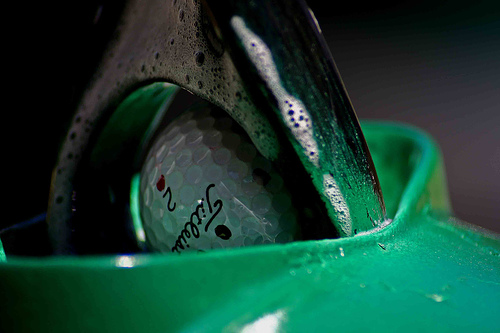<image>
Can you confirm if the ball is in the washer? Yes. The ball is contained within or inside the washer, showing a containment relationship. 